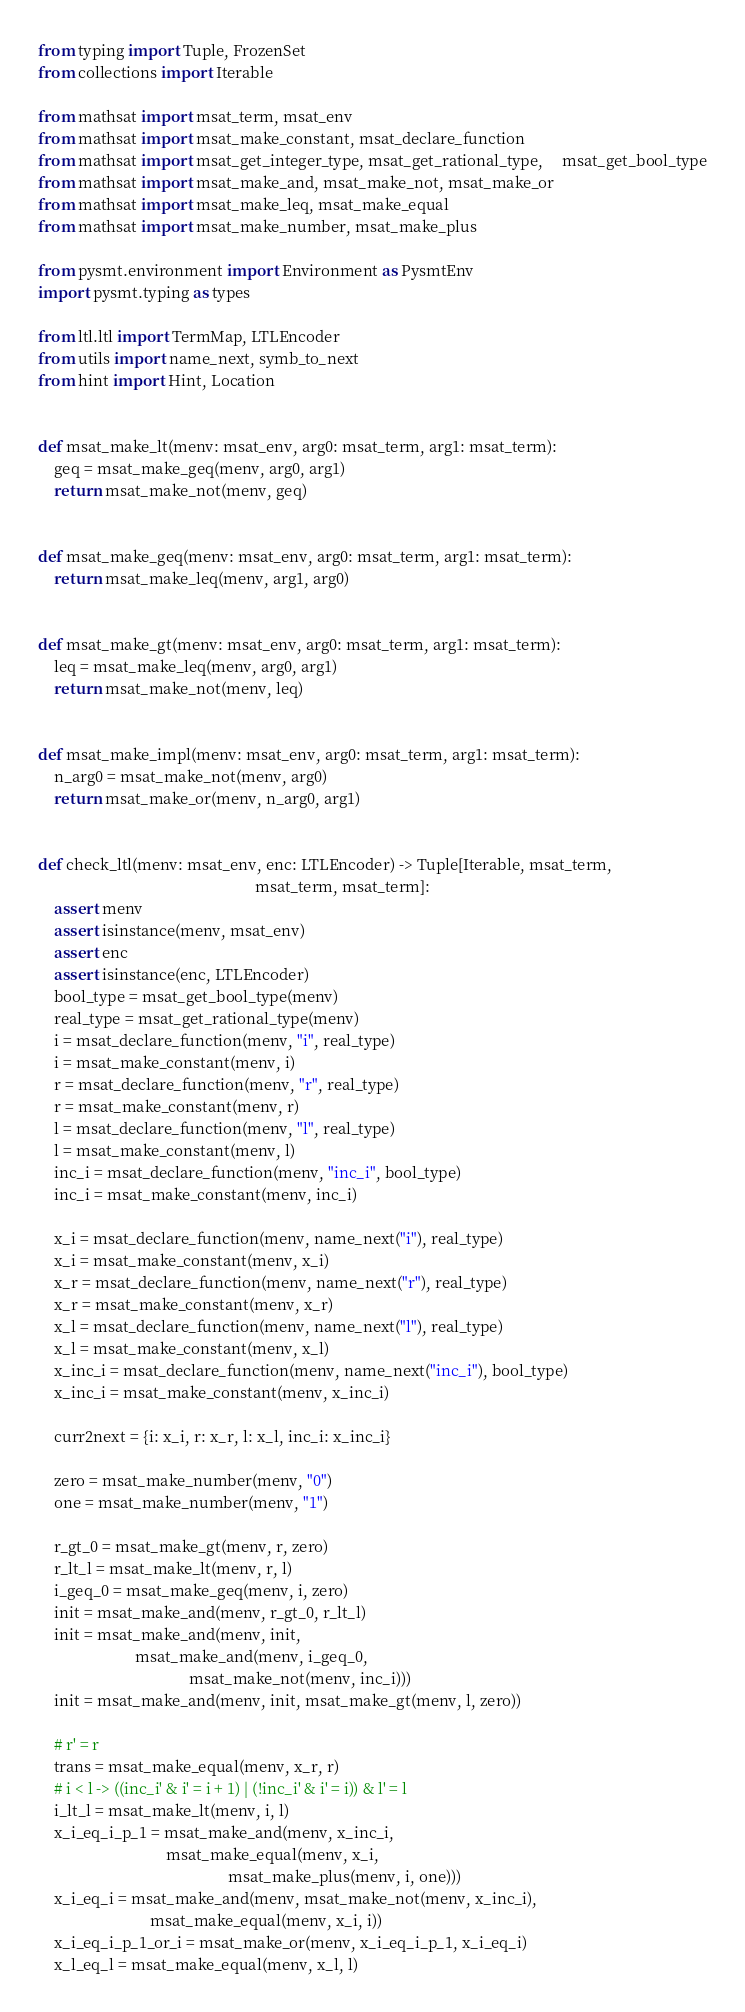Convert code to text. <code><loc_0><loc_0><loc_500><loc_500><_Python_>from typing import Tuple, FrozenSet
from collections import Iterable

from mathsat import msat_term, msat_env
from mathsat import msat_make_constant, msat_declare_function
from mathsat import msat_get_integer_type, msat_get_rational_type,     msat_get_bool_type
from mathsat import msat_make_and, msat_make_not, msat_make_or
from mathsat import msat_make_leq, msat_make_equal
from mathsat import msat_make_number, msat_make_plus

from pysmt.environment import Environment as PysmtEnv
import pysmt.typing as types

from ltl.ltl import TermMap, LTLEncoder
from utils import name_next, symb_to_next
from hint import Hint, Location


def msat_make_lt(menv: msat_env, arg0: msat_term, arg1: msat_term):
    geq = msat_make_geq(menv, arg0, arg1)
    return msat_make_not(menv, geq)


def msat_make_geq(menv: msat_env, arg0: msat_term, arg1: msat_term):
    return msat_make_leq(menv, arg1, arg0)


def msat_make_gt(menv: msat_env, arg0: msat_term, arg1: msat_term):
    leq = msat_make_leq(menv, arg0, arg1)
    return msat_make_not(menv, leq)


def msat_make_impl(menv: msat_env, arg0: msat_term, arg1: msat_term):
    n_arg0 = msat_make_not(menv, arg0)
    return msat_make_or(menv, n_arg0, arg1)


def check_ltl(menv: msat_env, enc: LTLEncoder) -> Tuple[Iterable, msat_term,
                                                        msat_term, msat_term]:
    assert menv
    assert isinstance(menv, msat_env)
    assert enc
    assert isinstance(enc, LTLEncoder)
    bool_type = msat_get_bool_type(menv)
    real_type = msat_get_rational_type(menv)
    i = msat_declare_function(menv, "i", real_type)
    i = msat_make_constant(menv, i)
    r = msat_declare_function(menv, "r", real_type)
    r = msat_make_constant(menv, r)
    l = msat_declare_function(menv, "l", real_type)
    l = msat_make_constant(menv, l)
    inc_i = msat_declare_function(menv, "inc_i", bool_type)
    inc_i = msat_make_constant(menv, inc_i)

    x_i = msat_declare_function(menv, name_next("i"), real_type)
    x_i = msat_make_constant(menv, x_i)
    x_r = msat_declare_function(menv, name_next("r"), real_type)
    x_r = msat_make_constant(menv, x_r)
    x_l = msat_declare_function(menv, name_next("l"), real_type)
    x_l = msat_make_constant(menv, x_l)
    x_inc_i = msat_declare_function(menv, name_next("inc_i"), bool_type)
    x_inc_i = msat_make_constant(menv, x_inc_i)

    curr2next = {i: x_i, r: x_r, l: x_l, inc_i: x_inc_i}

    zero = msat_make_number(menv, "0")
    one = msat_make_number(menv, "1")

    r_gt_0 = msat_make_gt(menv, r, zero)
    r_lt_l = msat_make_lt(menv, r, l)
    i_geq_0 = msat_make_geq(menv, i, zero)
    init = msat_make_and(menv, r_gt_0, r_lt_l)
    init = msat_make_and(menv, init,
                         msat_make_and(menv, i_geq_0,
                                       msat_make_not(menv, inc_i)))
    init = msat_make_and(menv, init, msat_make_gt(menv, l, zero))

    # r' = r
    trans = msat_make_equal(menv, x_r, r)
    # i < l -> ((inc_i' & i' = i + 1) | (!inc_i' & i' = i)) & l' = l
    i_lt_l = msat_make_lt(menv, i, l)
    x_i_eq_i_p_1 = msat_make_and(menv, x_inc_i,
                                 msat_make_equal(menv, x_i,
                                                 msat_make_plus(menv, i, one)))
    x_i_eq_i = msat_make_and(menv, msat_make_not(menv, x_inc_i),
                             msat_make_equal(menv, x_i, i))
    x_i_eq_i_p_1_or_i = msat_make_or(menv, x_i_eq_i_p_1, x_i_eq_i)
    x_l_eq_l = msat_make_equal(menv, x_l, l)</code> 